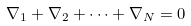<formula> <loc_0><loc_0><loc_500><loc_500>\nabla _ { 1 } + \nabla _ { 2 } + \dots + \nabla _ { N } = 0</formula> 